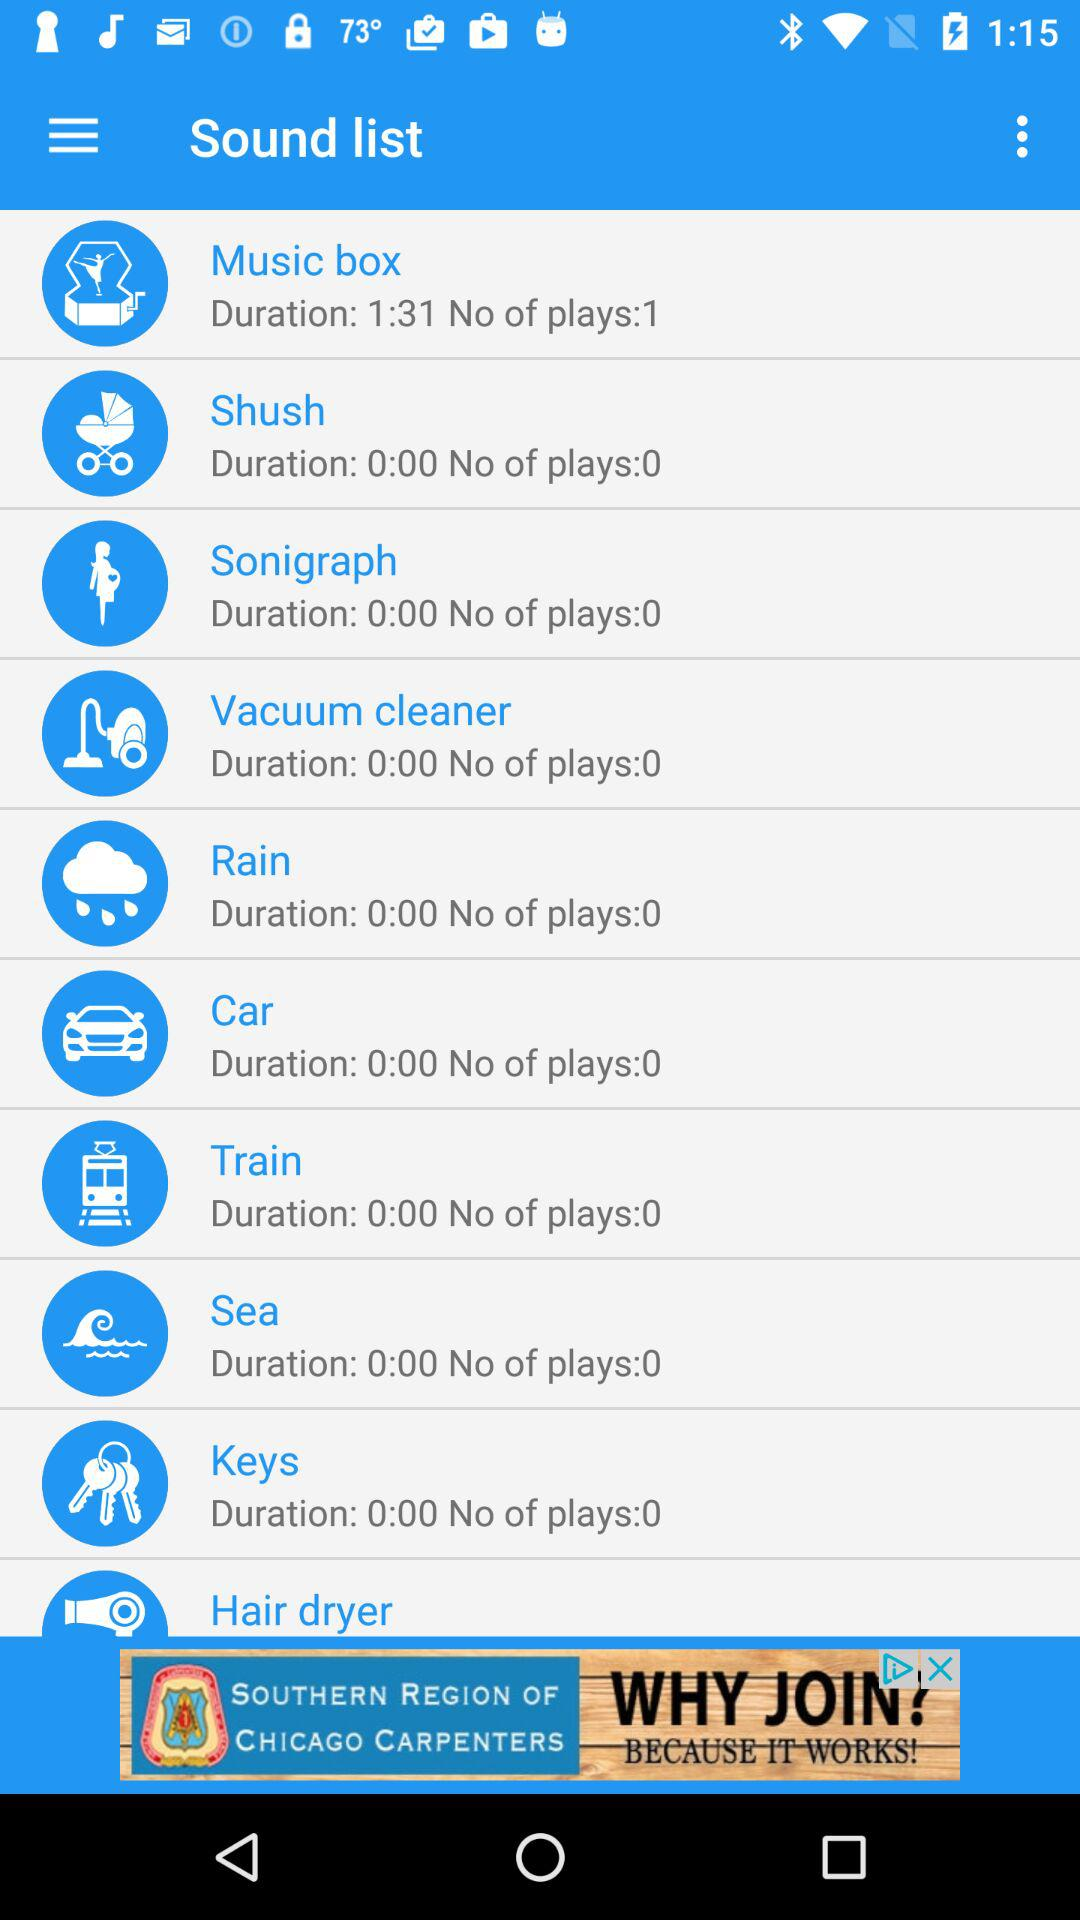Which item has the longest duration?
Answer the question using a single word or phrase. Music box 